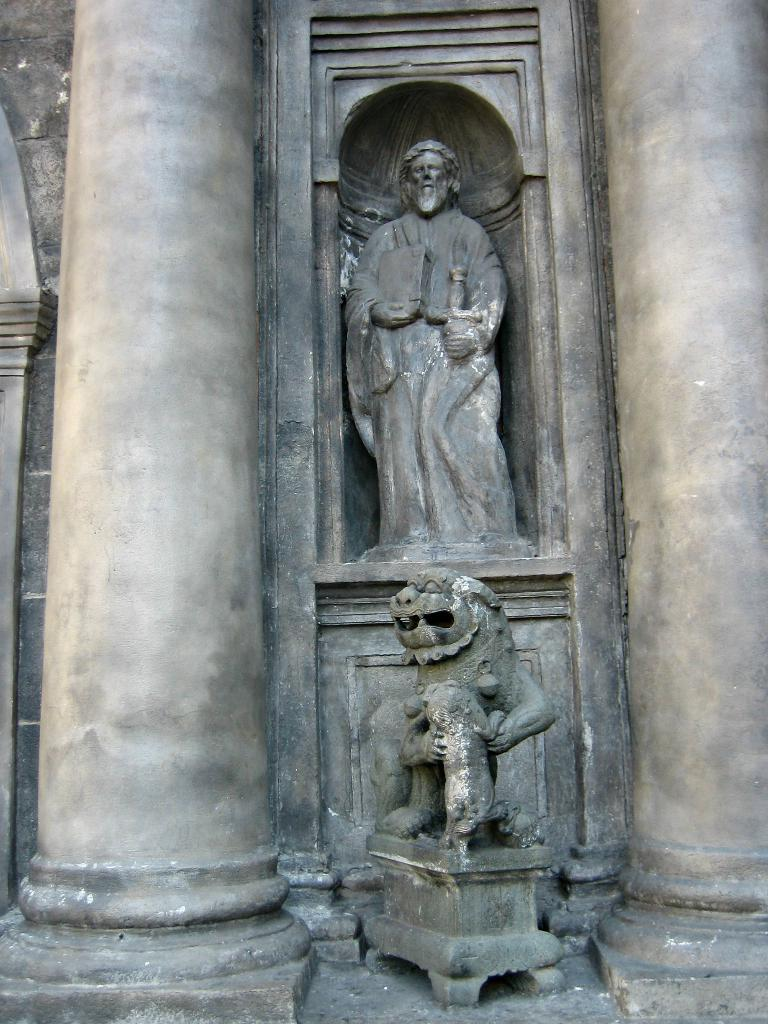What architectural elements can be seen in the image? There are pillars and a wall in the image. What type of decorative objects are present in the image? There are statues in the image. How many toys can be seen on the table in the image? There is no table or toys present in the image. What type of flock is visible in the image? There is no flock present in the image. 